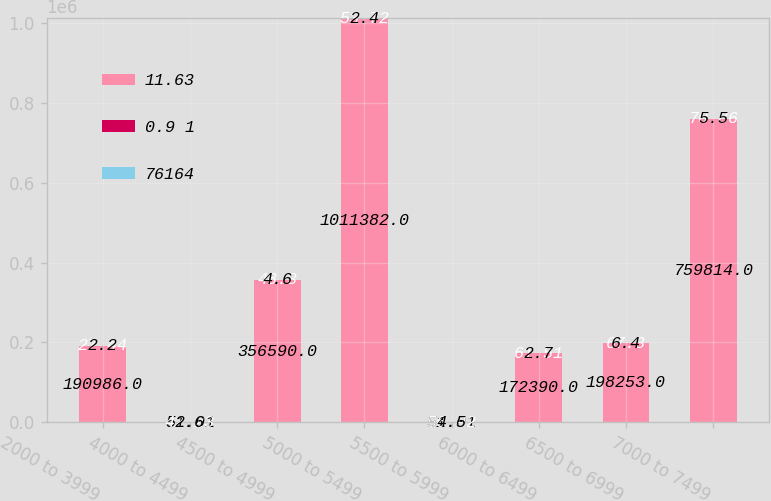<chart> <loc_0><loc_0><loc_500><loc_500><stacked_bar_chart><ecel><fcel>2000 to 3999<fcel>4000 to 4499<fcel>4500 to 4999<fcel>5000 to 5499<fcel>5500 to 5999<fcel>6000 to 6499<fcel>6500 to 6999<fcel>7000 to 7499<nl><fcel>11.63<fcel>190986<fcel>51.01<fcel>356590<fcel>1.01138e+06<fcel>51.01<fcel>172390<fcel>198253<fcel>759814<nl><fcel>0.9 1<fcel>27.44<fcel>42.23<fcel>48.3<fcel>53.72<fcel>56.92<fcel>61.51<fcel>67.3<fcel>70.86<nl><fcel>76164<fcel>2.2<fcel>2.6<fcel>4.6<fcel>2.4<fcel>4.5<fcel>2.7<fcel>6.4<fcel>5.5<nl></chart> 